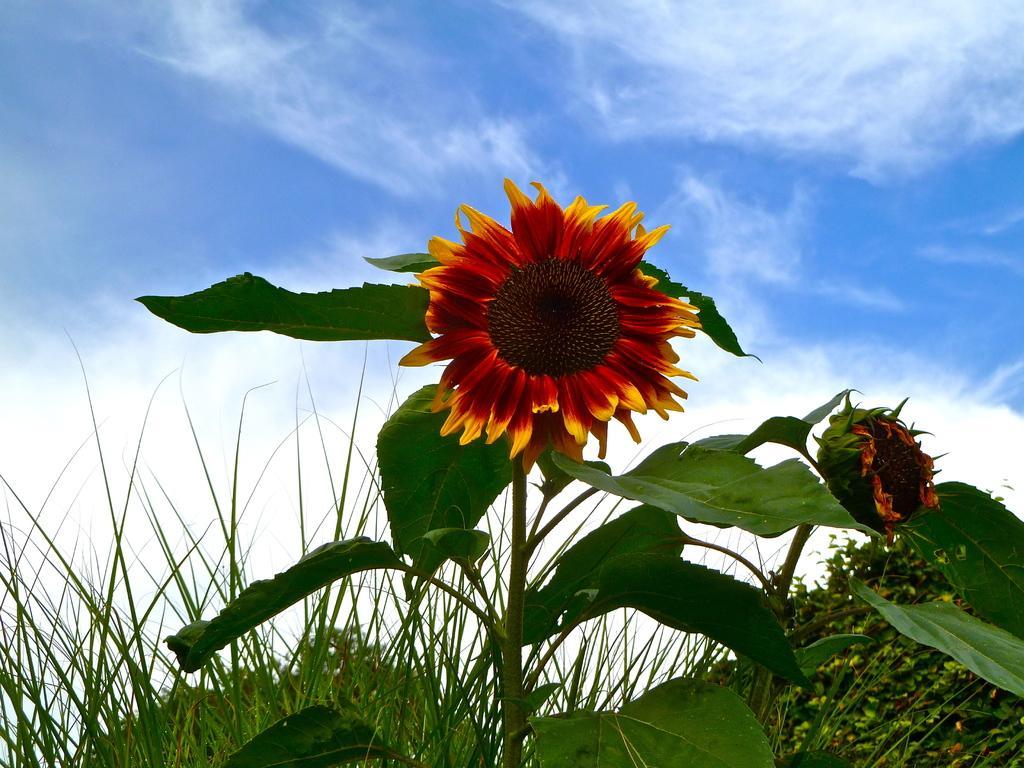Can you describe this image briefly? In the center of the image we can see sunflower. In the background we can see sky, clouds and plants. 